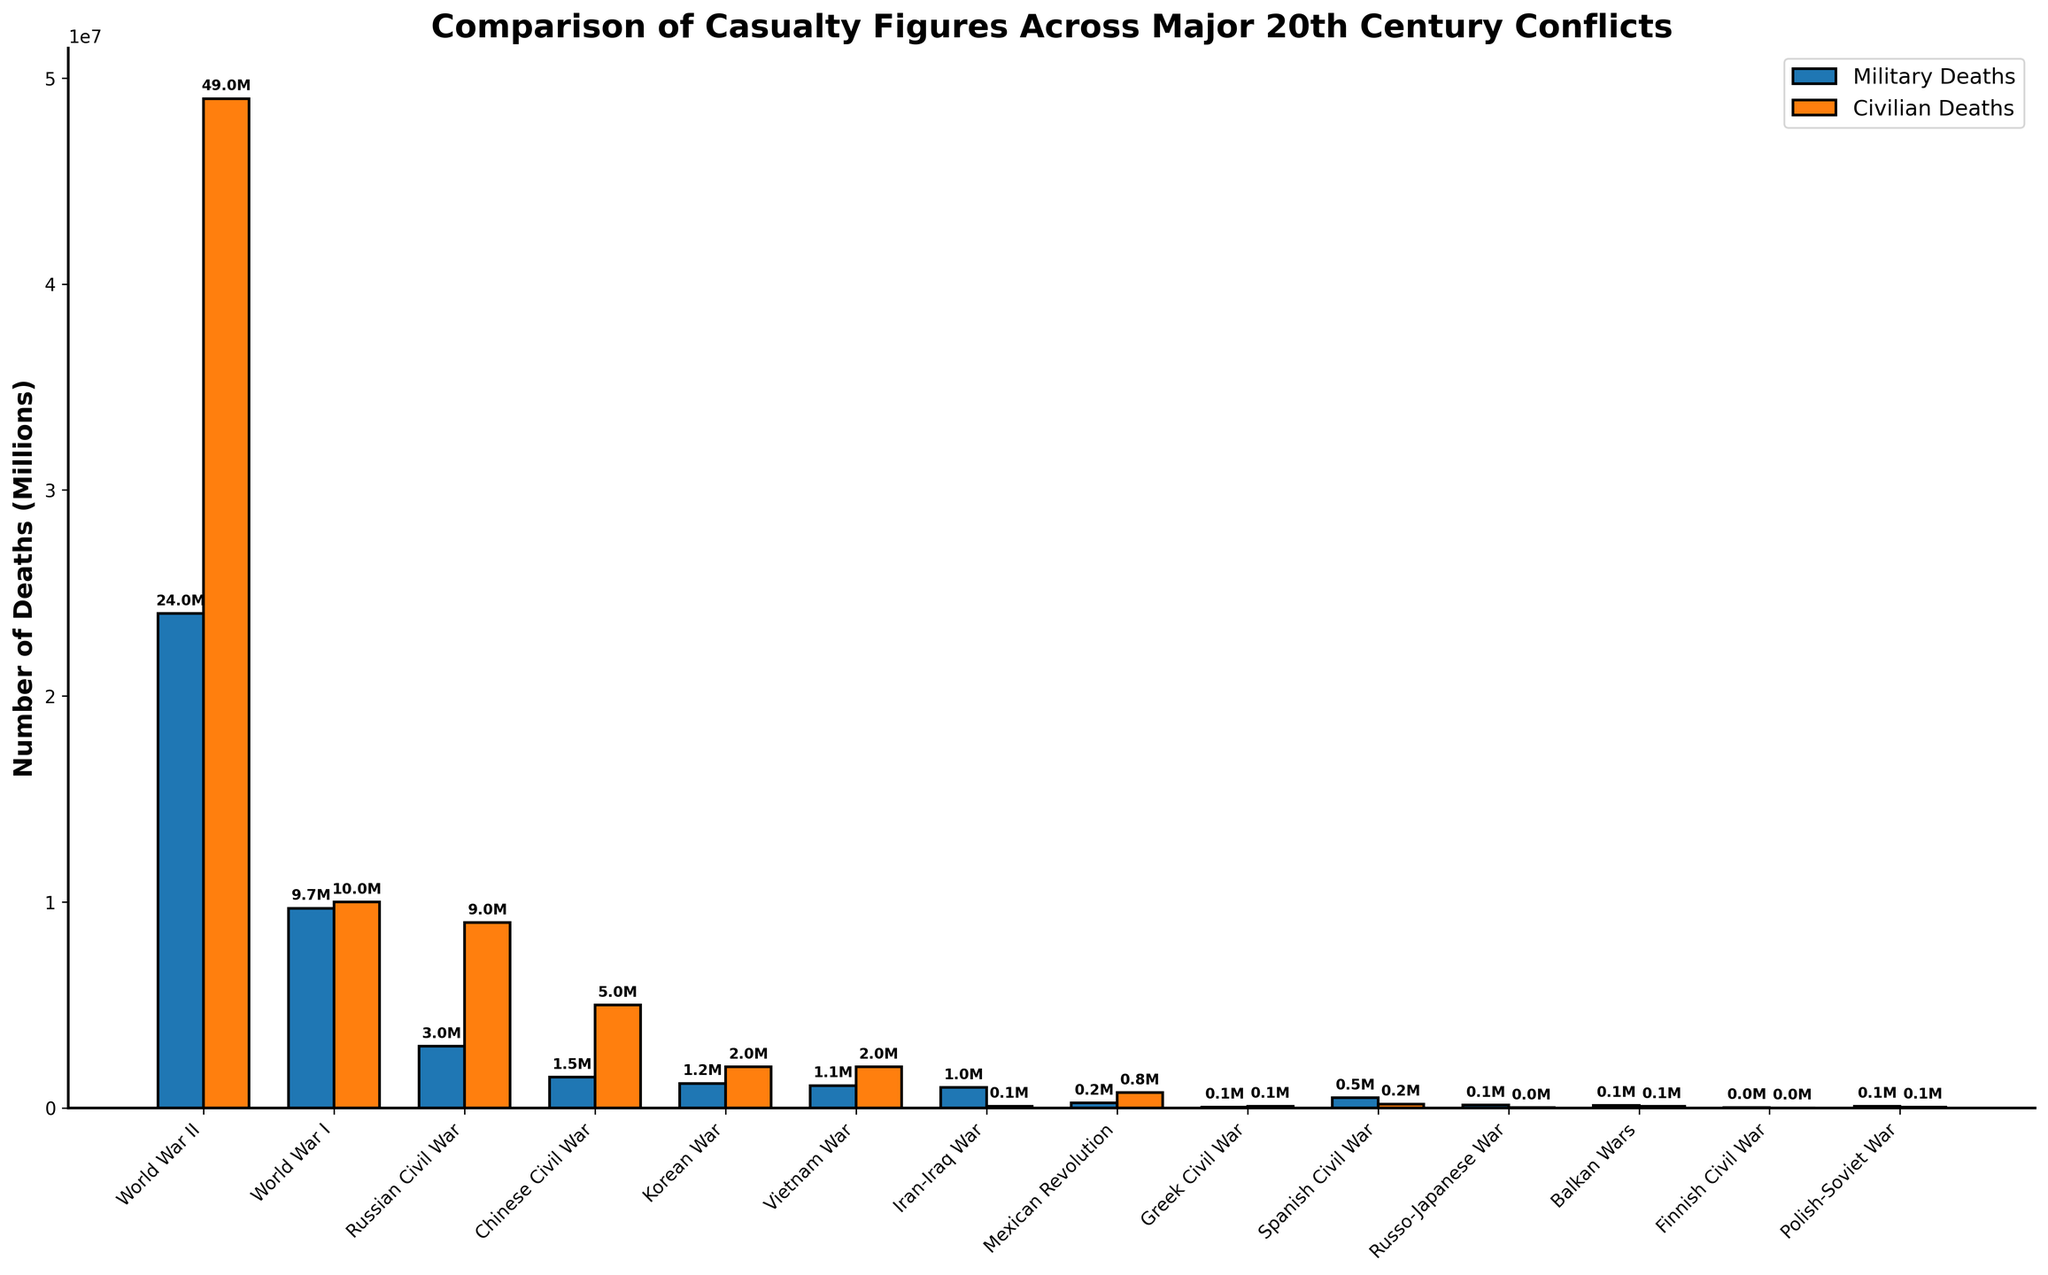Which conflict had the highest number of civilian deaths? By examining the height of the bars representing civilian deaths, the conflict with the tallest bar signifies the highest number of civilian deaths. In this case, the World War II bar for civilian deaths is the tallest.
Answer: World War II What is the difference in military deaths between World War I and the Vietnam War? To find the difference, locate the bars for military deaths of both conflicts and subtract the Vietnam War military deaths (1,100,000) from World War I military deaths (9,700,000).
Answer: 8.6 million Which conflict had more military deaths: the Mexican Revolution or the Greek Civil War? Compare the heights of the bars for military deaths of both conflicts. The bar for the Mexican Revolution (250,000) is taller than that of the Greek Civil War (50,000).
Answer: Mexican Revolution Are there more conflicts with higher military deaths than civilian deaths or vice versa? Count the number of conflicts where the military deaths bar is taller than the civilian deaths bar and compare it to the conflicts where the civilian deaths bar is taller.
Answer: More conflicts have higher civilian deaths What are the total military deaths across all conflicts? Sum the heights of the military deaths bars for all conflicts. The sum is: 24,000,000 + 9,700,000 + 3,000,000 + 1,500,000 + 1,200,000 + 1,100,000 + 1,000,000 + 250,000 + 50,000 + 500,000 + 150,000 + 140,000 + 36,000 + 100,000.
Answer: 42.726 million Which conflict had the lowest combined military and civilian deaths? Add the heights of both bars for military and civilian deaths for each conflict, then identify the smallest sum. The Finnish Civil War has the lowest combined total (36,000 + 11,000).
Answer: Finnish Civil War How do civilian deaths in the Russian Civil War compare to those in the Chinese Civil War? Compare the heights of the bars for civilian deaths of the Russian Civil War (9,000,000) and the Chinese Civil War (5,000,000).
Answer: Higher in the Russian Civil War What is the average number of military deaths across all conflicts? Sum the military deaths (42,726,000) and divide by the number of conflicts (14).
Answer: Approximately 3.05 million Which conflict had nearly equal military and civilian deaths? Identify the conflicts where the bars for military and civilian deaths are nearly the same height. The Spanish Civil War shows the closest values (500,000 military, 200,000 civilian).
Answer: Spanish Civil War 